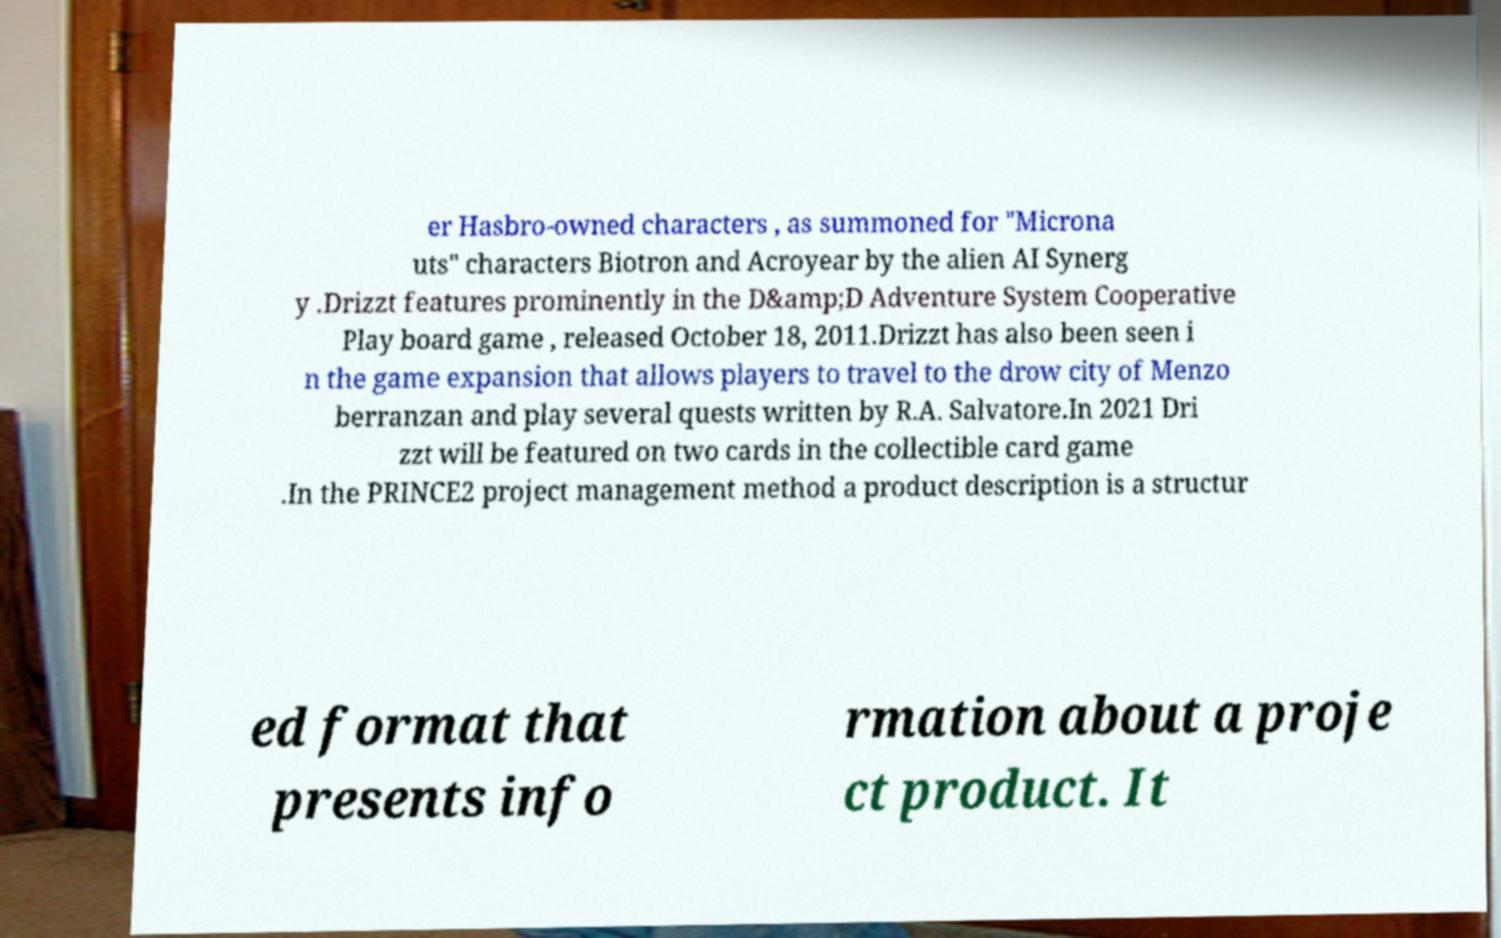I need the written content from this picture converted into text. Can you do that? er Hasbro-owned characters , as summoned for "Microna uts" characters Biotron and Acroyear by the alien AI Synerg y .Drizzt features prominently in the D&amp;D Adventure System Cooperative Play board game , released October 18, 2011.Drizzt has also been seen i n the game expansion that allows players to travel to the drow city of Menzo berranzan and play several quests written by R.A. Salvatore.In 2021 Dri zzt will be featured on two cards in the collectible card game .In the PRINCE2 project management method a product description is a structur ed format that presents info rmation about a proje ct product. It 